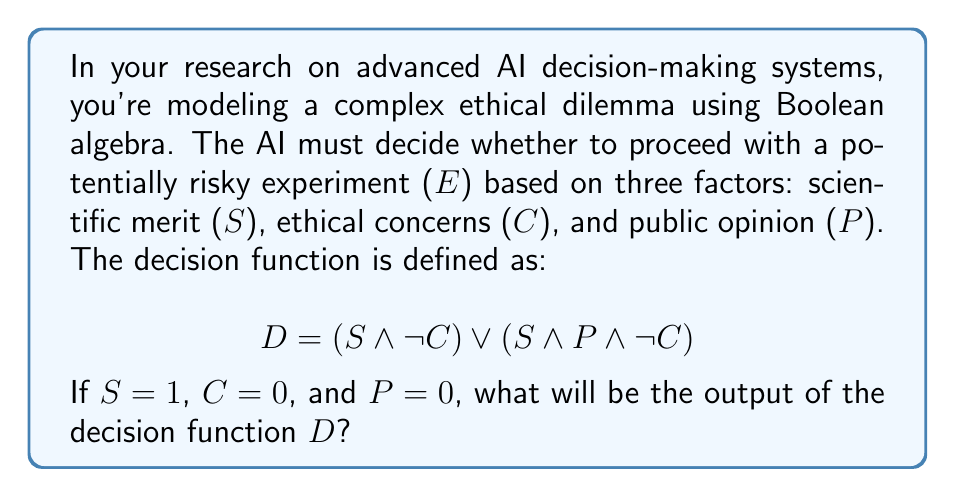Give your solution to this math problem. Let's approach this step-by-step:

1) We are given the following values:
   S = 1 (True)
   C = 0 (False)
   P = 0 (False)

2) Let's substitute these values into our decision function:
   $$D = (S \land \neg C) \lor (S \land P \land \neg C)$$

3) First, let's evaluate $\neg C$:
   $\neg C = \neg 0 = 1$

4) Now, let's evaluate the first part of the function: $(S \land \neg C)$
   $(1 \land 1) = 1$

5) Next, let's evaluate the second part: $(S \land P \land \neg C)$
   $(1 \land 0 \land 1) = 0$

6) Now our function looks like this:
   $$D = 1 \lor 0$$

7) The OR operation ($\lor$) returns 1 if either of its inputs is 1:
   $$1 \lor 0 = 1$$

Therefore, the output of the decision function D is 1 (True).
Answer: 1 